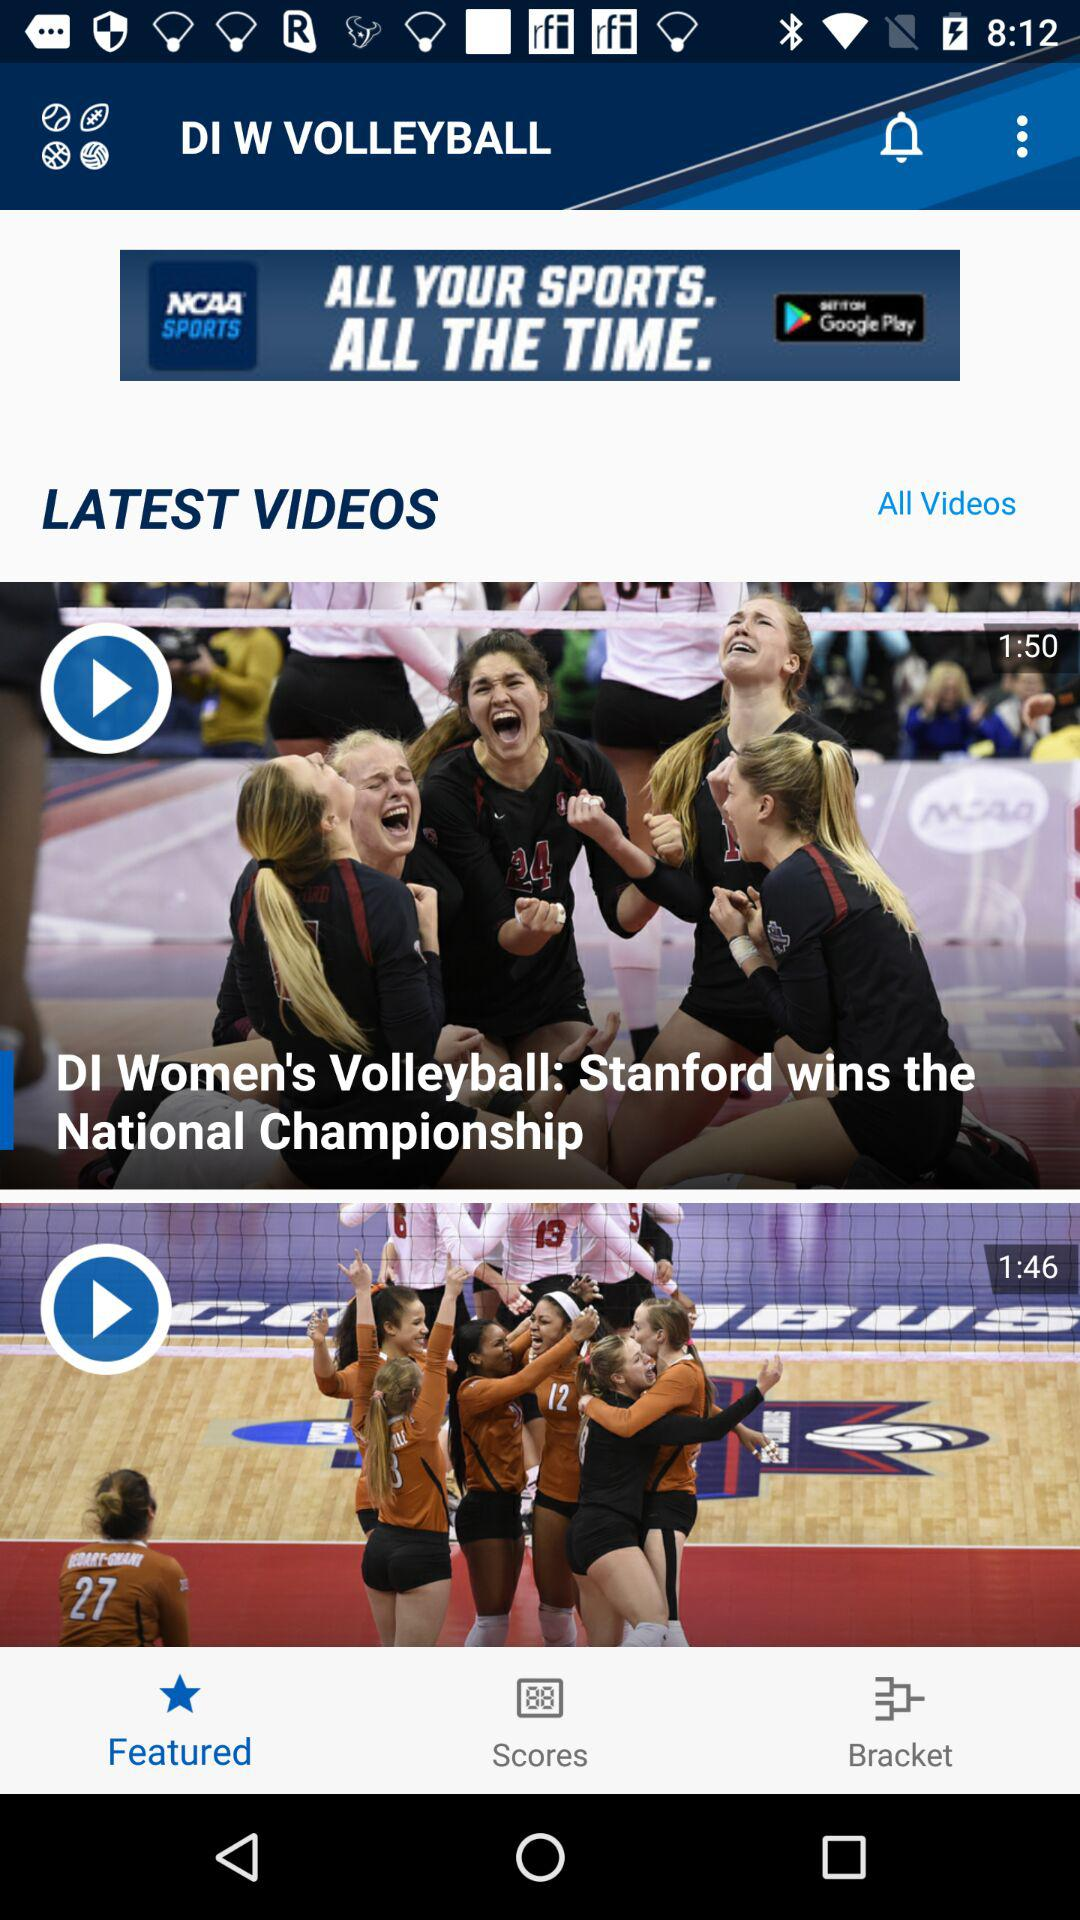Which tab has been selected? The selected tab is "Featured". 